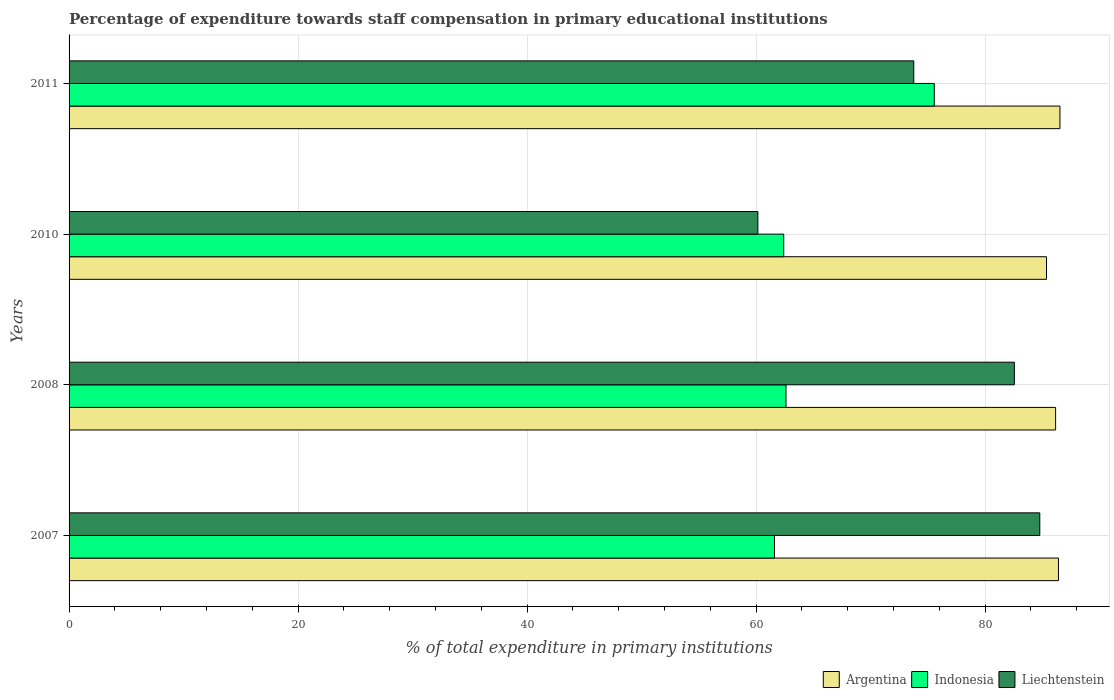How many different coloured bars are there?
Give a very brief answer. 3. How many groups of bars are there?
Keep it short and to the point. 4. Are the number of bars per tick equal to the number of legend labels?
Ensure brevity in your answer.  Yes. Are the number of bars on each tick of the Y-axis equal?
Offer a very short reply. Yes. How many bars are there on the 4th tick from the top?
Offer a terse response. 3. How many bars are there on the 1st tick from the bottom?
Your answer should be very brief. 3. What is the label of the 2nd group of bars from the top?
Your answer should be compact. 2010. In how many cases, is the number of bars for a given year not equal to the number of legend labels?
Your response must be concise. 0. What is the percentage of expenditure towards staff compensation in Argentina in 2008?
Give a very brief answer. 86.15. Across all years, what is the maximum percentage of expenditure towards staff compensation in Liechtenstein?
Offer a terse response. 84.77. Across all years, what is the minimum percentage of expenditure towards staff compensation in Indonesia?
Give a very brief answer. 61.6. What is the total percentage of expenditure towards staff compensation in Argentina in the graph?
Your answer should be compact. 344.44. What is the difference between the percentage of expenditure towards staff compensation in Argentina in 2010 and that in 2011?
Offer a terse response. -1.17. What is the difference between the percentage of expenditure towards staff compensation in Liechtenstein in 2010 and the percentage of expenditure towards staff compensation in Argentina in 2008?
Your response must be concise. -26. What is the average percentage of expenditure towards staff compensation in Argentina per year?
Your response must be concise. 86.11. In the year 2007, what is the difference between the percentage of expenditure towards staff compensation in Indonesia and percentage of expenditure towards staff compensation in Liechtenstein?
Your response must be concise. -23.17. In how many years, is the percentage of expenditure towards staff compensation in Argentina greater than 48 %?
Make the answer very short. 4. What is the ratio of the percentage of expenditure towards staff compensation in Indonesia in 2010 to that in 2011?
Make the answer very short. 0.83. Is the percentage of expenditure towards staff compensation in Liechtenstein in 2007 less than that in 2010?
Give a very brief answer. No. Is the difference between the percentage of expenditure towards staff compensation in Indonesia in 2007 and 2010 greater than the difference between the percentage of expenditure towards staff compensation in Liechtenstein in 2007 and 2010?
Provide a short and direct response. No. What is the difference between the highest and the second highest percentage of expenditure towards staff compensation in Indonesia?
Make the answer very short. 12.95. What is the difference between the highest and the lowest percentage of expenditure towards staff compensation in Indonesia?
Provide a succinct answer. 13.95. Is it the case that in every year, the sum of the percentage of expenditure towards staff compensation in Indonesia and percentage of expenditure towards staff compensation in Liechtenstein is greater than the percentage of expenditure towards staff compensation in Argentina?
Provide a short and direct response. Yes. How many bars are there?
Your answer should be very brief. 12. How many years are there in the graph?
Your answer should be compact. 4. Are the values on the major ticks of X-axis written in scientific E-notation?
Offer a very short reply. No. Does the graph contain any zero values?
Provide a short and direct response. No. Where does the legend appear in the graph?
Make the answer very short. Bottom right. How are the legend labels stacked?
Provide a succinct answer. Horizontal. What is the title of the graph?
Make the answer very short. Percentage of expenditure towards staff compensation in primary educational institutions. What is the label or title of the X-axis?
Your answer should be compact. % of total expenditure in primary institutions. What is the % of total expenditure in primary institutions in Argentina in 2007?
Your answer should be compact. 86.4. What is the % of total expenditure in primary institutions of Indonesia in 2007?
Provide a succinct answer. 61.6. What is the % of total expenditure in primary institutions of Liechtenstein in 2007?
Make the answer very short. 84.77. What is the % of total expenditure in primary institutions of Argentina in 2008?
Offer a terse response. 86.15. What is the % of total expenditure in primary institutions in Indonesia in 2008?
Offer a very short reply. 62.61. What is the % of total expenditure in primary institutions of Liechtenstein in 2008?
Make the answer very short. 82.55. What is the % of total expenditure in primary institutions in Argentina in 2010?
Offer a very short reply. 85.36. What is the % of total expenditure in primary institutions in Indonesia in 2010?
Provide a short and direct response. 62.41. What is the % of total expenditure in primary institutions of Liechtenstein in 2010?
Keep it short and to the point. 60.15. What is the % of total expenditure in primary institutions in Argentina in 2011?
Give a very brief answer. 86.53. What is the % of total expenditure in primary institutions in Indonesia in 2011?
Give a very brief answer. 75.56. What is the % of total expenditure in primary institutions in Liechtenstein in 2011?
Your response must be concise. 73.76. Across all years, what is the maximum % of total expenditure in primary institutions of Argentina?
Offer a very short reply. 86.53. Across all years, what is the maximum % of total expenditure in primary institutions in Indonesia?
Offer a terse response. 75.56. Across all years, what is the maximum % of total expenditure in primary institutions of Liechtenstein?
Provide a short and direct response. 84.77. Across all years, what is the minimum % of total expenditure in primary institutions in Argentina?
Provide a short and direct response. 85.36. Across all years, what is the minimum % of total expenditure in primary institutions in Indonesia?
Provide a succinct answer. 61.6. Across all years, what is the minimum % of total expenditure in primary institutions of Liechtenstein?
Your answer should be very brief. 60.15. What is the total % of total expenditure in primary institutions of Argentina in the graph?
Provide a short and direct response. 344.44. What is the total % of total expenditure in primary institutions in Indonesia in the graph?
Your response must be concise. 262.17. What is the total % of total expenditure in primary institutions in Liechtenstein in the graph?
Provide a short and direct response. 301.24. What is the difference between the % of total expenditure in primary institutions of Argentina in 2007 and that in 2008?
Your answer should be compact. 0.25. What is the difference between the % of total expenditure in primary institutions in Indonesia in 2007 and that in 2008?
Keep it short and to the point. -1.01. What is the difference between the % of total expenditure in primary institutions of Liechtenstein in 2007 and that in 2008?
Offer a terse response. 2.22. What is the difference between the % of total expenditure in primary institutions in Argentina in 2007 and that in 2010?
Your response must be concise. 1.04. What is the difference between the % of total expenditure in primary institutions in Indonesia in 2007 and that in 2010?
Offer a very short reply. -0.81. What is the difference between the % of total expenditure in primary institutions of Liechtenstein in 2007 and that in 2010?
Make the answer very short. 24.62. What is the difference between the % of total expenditure in primary institutions in Argentina in 2007 and that in 2011?
Your answer should be compact. -0.13. What is the difference between the % of total expenditure in primary institutions of Indonesia in 2007 and that in 2011?
Offer a very short reply. -13.95. What is the difference between the % of total expenditure in primary institutions in Liechtenstein in 2007 and that in 2011?
Make the answer very short. 11.01. What is the difference between the % of total expenditure in primary institutions of Argentina in 2008 and that in 2010?
Your response must be concise. 0.8. What is the difference between the % of total expenditure in primary institutions in Indonesia in 2008 and that in 2010?
Your response must be concise. 0.2. What is the difference between the % of total expenditure in primary institutions in Liechtenstein in 2008 and that in 2010?
Give a very brief answer. 22.4. What is the difference between the % of total expenditure in primary institutions in Argentina in 2008 and that in 2011?
Provide a short and direct response. -0.38. What is the difference between the % of total expenditure in primary institutions of Indonesia in 2008 and that in 2011?
Provide a succinct answer. -12.95. What is the difference between the % of total expenditure in primary institutions of Liechtenstein in 2008 and that in 2011?
Keep it short and to the point. 8.79. What is the difference between the % of total expenditure in primary institutions in Argentina in 2010 and that in 2011?
Provide a short and direct response. -1.17. What is the difference between the % of total expenditure in primary institutions in Indonesia in 2010 and that in 2011?
Provide a succinct answer. -13.15. What is the difference between the % of total expenditure in primary institutions of Liechtenstein in 2010 and that in 2011?
Your answer should be very brief. -13.61. What is the difference between the % of total expenditure in primary institutions of Argentina in 2007 and the % of total expenditure in primary institutions of Indonesia in 2008?
Keep it short and to the point. 23.79. What is the difference between the % of total expenditure in primary institutions in Argentina in 2007 and the % of total expenditure in primary institutions in Liechtenstein in 2008?
Keep it short and to the point. 3.85. What is the difference between the % of total expenditure in primary institutions in Indonesia in 2007 and the % of total expenditure in primary institutions in Liechtenstein in 2008?
Make the answer very short. -20.95. What is the difference between the % of total expenditure in primary institutions of Argentina in 2007 and the % of total expenditure in primary institutions of Indonesia in 2010?
Give a very brief answer. 23.99. What is the difference between the % of total expenditure in primary institutions in Argentina in 2007 and the % of total expenditure in primary institutions in Liechtenstein in 2010?
Your response must be concise. 26.25. What is the difference between the % of total expenditure in primary institutions in Indonesia in 2007 and the % of total expenditure in primary institutions in Liechtenstein in 2010?
Keep it short and to the point. 1.45. What is the difference between the % of total expenditure in primary institutions of Argentina in 2007 and the % of total expenditure in primary institutions of Indonesia in 2011?
Ensure brevity in your answer.  10.84. What is the difference between the % of total expenditure in primary institutions in Argentina in 2007 and the % of total expenditure in primary institutions in Liechtenstein in 2011?
Provide a short and direct response. 12.64. What is the difference between the % of total expenditure in primary institutions in Indonesia in 2007 and the % of total expenditure in primary institutions in Liechtenstein in 2011?
Your answer should be very brief. -12.16. What is the difference between the % of total expenditure in primary institutions in Argentina in 2008 and the % of total expenditure in primary institutions in Indonesia in 2010?
Keep it short and to the point. 23.74. What is the difference between the % of total expenditure in primary institutions in Argentina in 2008 and the % of total expenditure in primary institutions in Liechtenstein in 2010?
Give a very brief answer. 26. What is the difference between the % of total expenditure in primary institutions of Indonesia in 2008 and the % of total expenditure in primary institutions of Liechtenstein in 2010?
Provide a succinct answer. 2.46. What is the difference between the % of total expenditure in primary institutions in Argentina in 2008 and the % of total expenditure in primary institutions in Indonesia in 2011?
Your response must be concise. 10.59. What is the difference between the % of total expenditure in primary institutions of Argentina in 2008 and the % of total expenditure in primary institutions of Liechtenstein in 2011?
Make the answer very short. 12.39. What is the difference between the % of total expenditure in primary institutions in Indonesia in 2008 and the % of total expenditure in primary institutions in Liechtenstein in 2011?
Offer a terse response. -11.16. What is the difference between the % of total expenditure in primary institutions of Argentina in 2010 and the % of total expenditure in primary institutions of Indonesia in 2011?
Keep it short and to the point. 9.8. What is the difference between the % of total expenditure in primary institutions in Argentina in 2010 and the % of total expenditure in primary institutions in Liechtenstein in 2011?
Offer a terse response. 11.59. What is the difference between the % of total expenditure in primary institutions of Indonesia in 2010 and the % of total expenditure in primary institutions of Liechtenstein in 2011?
Provide a short and direct response. -11.36. What is the average % of total expenditure in primary institutions of Argentina per year?
Make the answer very short. 86.11. What is the average % of total expenditure in primary institutions in Indonesia per year?
Your answer should be compact. 65.54. What is the average % of total expenditure in primary institutions in Liechtenstein per year?
Keep it short and to the point. 75.31. In the year 2007, what is the difference between the % of total expenditure in primary institutions in Argentina and % of total expenditure in primary institutions in Indonesia?
Ensure brevity in your answer.  24.8. In the year 2007, what is the difference between the % of total expenditure in primary institutions of Argentina and % of total expenditure in primary institutions of Liechtenstein?
Your response must be concise. 1.63. In the year 2007, what is the difference between the % of total expenditure in primary institutions in Indonesia and % of total expenditure in primary institutions in Liechtenstein?
Ensure brevity in your answer.  -23.17. In the year 2008, what is the difference between the % of total expenditure in primary institutions of Argentina and % of total expenditure in primary institutions of Indonesia?
Offer a very short reply. 23.54. In the year 2008, what is the difference between the % of total expenditure in primary institutions in Argentina and % of total expenditure in primary institutions in Liechtenstein?
Your response must be concise. 3.6. In the year 2008, what is the difference between the % of total expenditure in primary institutions in Indonesia and % of total expenditure in primary institutions in Liechtenstein?
Make the answer very short. -19.94. In the year 2010, what is the difference between the % of total expenditure in primary institutions in Argentina and % of total expenditure in primary institutions in Indonesia?
Offer a terse response. 22.95. In the year 2010, what is the difference between the % of total expenditure in primary institutions in Argentina and % of total expenditure in primary institutions in Liechtenstein?
Your answer should be compact. 25.21. In the year 2010, what is the difference between the % of total expenditure in primary institutions of Indonesia and % of total expenditure in primary institutions of Liechtenstein?
Your answer should be compact. 2.26. In the year 2011, what is the difference between the % of total expenditure in primary institutions in Argentina and % of total expenditure in primary institutions in Indonesia?
Give a very brief answer. 10.97. In the year 2011, what is the difference between the % of total expenditure in primary institutions of Argentina and % of total expenditure in primary institutions of Liechtenstein?
Keep it short and to the point. 12.77. In the year 2011, what is the difference between the % of total expenditure in primary institutions in Indonesia and % of total expenditure in primary institutions in Liechtenstein?
Your response must be concise. 1.79. What is the ratio of the % of total expenditure in primary institutions of Indonesia in 2007 to that in 2008?
Offer a terse response. 0.98. What is the ratio of the % of total expenditure in primary institutions of Liechtenstein in 2007 to that in 2008?
Offer a very short reply. 1.03. What is the ratio of the % of total expenditure in primary institutions of Argentina in 2007 to that in 2010?
Offer a very short reply. 1.01. What is the ratio of the % of total expenditure in primary institutions of Indonesia in 2007 to that in 2010?
Give a very brief answer. 0.99. What is the ratio of the % of total expenditure in primary institutions of Liechtenstein in 2007 to that in 2010?
Offer a very short reply. 1.41. What is the ratio of the % of total expenditure in primary institutions in Argentina in 2007 to that in 2011?
Keep it short and to the point. 1. What is the ratio of the % of total expenditure in primary institutions in Indonesia in 2007 to that in 2011?
Provide a succinct answer. 0.82. What is the ratio of the % of total expenditure in primary institutions in Liechtenstein in 2007 to that in 2011?
Give a very brief answer. 1.15. What is the ratio of the % of total expenditure in primary institutions in Argentina in 2008 to that in 2010?
Your answer should be very brief. 1.01. What is the ratio of the % of total expenditure in primary institutions of Liechtenstein in 2008 to that in 2010?
Ensure brevity in your answer.  1.37. What is the ratio of the % of total expenditure in primary institutions in Argentina in 2008 to that in 2011?
Your response must be concise. 1. What is the ratio of the % of total expenditure in primary institutions of Indonesia in 2008 to that in 2011?
Ensure brevity in your answer.  0.83. What is the ratio of the % of total expenditure in primary institutions in Liechtenstein in 2008 to that in 2011?
Give a very brief answer. 1.12. What is the ratio of the % of total expenditure in primary institutions of Argentina in 2010 to that in 2011?
Your answer should be very brief. 0.99. What is the ratio of the % of total expenditure in primary institutions in Indonesia in 2010 to that in 2011?
Give a very brief answer. 0.83. What is the ratio of the % of total expenditure in primary institutions of Liechtenstein in 2010 to that in 2011?
Make the answer very short. 0.82. What is the difference between the highest and the second highest % of total expenditure in primary institutions of Argentina?
Give a very brief answer. 0.13. What is the difference between the highest and the second highest % of total expenditure in primary institutions of Indonesia?
Provide a short and direct response. 12.95. What is the difference between the highest and the second highest % of total expenditure in primary institutions in Liechtenstein?
Your answer should be compact. 2.22. What is the difference between the highest and the lowest % of total expenditure in primary institutions of Argentina?
Make the answer very short. 1.17. What is the difference between the highest and the lowest % of total expenditure in primary institutions of Indonesia?
Give a very brief answer. 13.95. What is the difference between the highest and the lowest % of total expenditure in primary institutions in Liechtenstein?
Give a very brief answer. 24.62. 